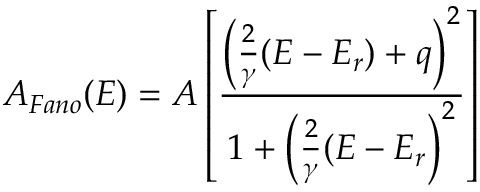<formula> <loc_0><loc_0><loc_500><loc_500>A _ { F a n o } ( E ) = A \left [ \frac { \left ( \frac { 2 } { \gamma } ( E - E _ { r } ) + q \right ) ^ { 2 } } { 1 + \left ( \frac { 2 } { \gamma } ( E - E _ { r } \right ) ^ { 2 } } \right ]</formula> 